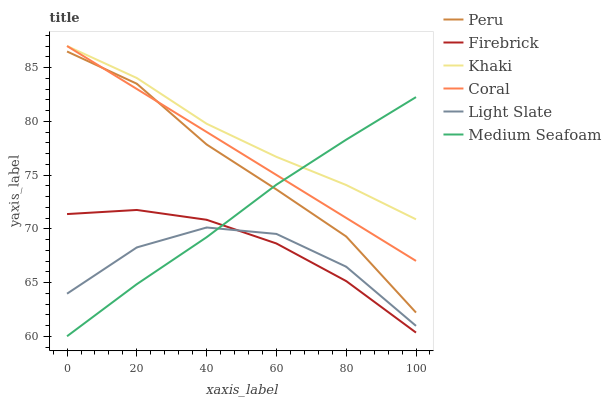Does Light Slate have the minimum area under the curve?
Answer yes or no. Yes. Does Khaki have the maximum area under the curve?
Answer yes or no. Yes. Does Firebrick have the minimum area under the curve?
Answer yes or no. No. Does Firebrick have the maximum area under the curve?
Answer yes or no. No. Is Coral the smoothest?
Answer yes or no. Yes. Is Light Slate the roughest?
Answer yes or no. Yes. Is Firebrick the smoothest?
Answer yes or no. No. Is Firebrick the roughest?
Answer yes or no. No. Does Medium Seafoam have the lowest value?
Answer yes or no. Yes. Does Light Slate have the lowest value?
Answer yes or no. No. Does Coral have the highest value?
Answer yes or no. Yes. Does Firebrick have the highest value?
Answer yes or no. No. Is Firebrick less than Peru?
Answer yes or no. Yes. Is Peru greater than Firebrick?
Answer yes or no. Yes. Does Light Slate intersect Medium Seafoam?
Answer yes or no. Yes. Is Light Slate less than Medium Seafoam?
Answer yes or no. No. Is Light Slate greater than Medium Seafoam?
Answer yes or no. No. Does Firebrick intersect Peru?
Answer yes or no. No. 